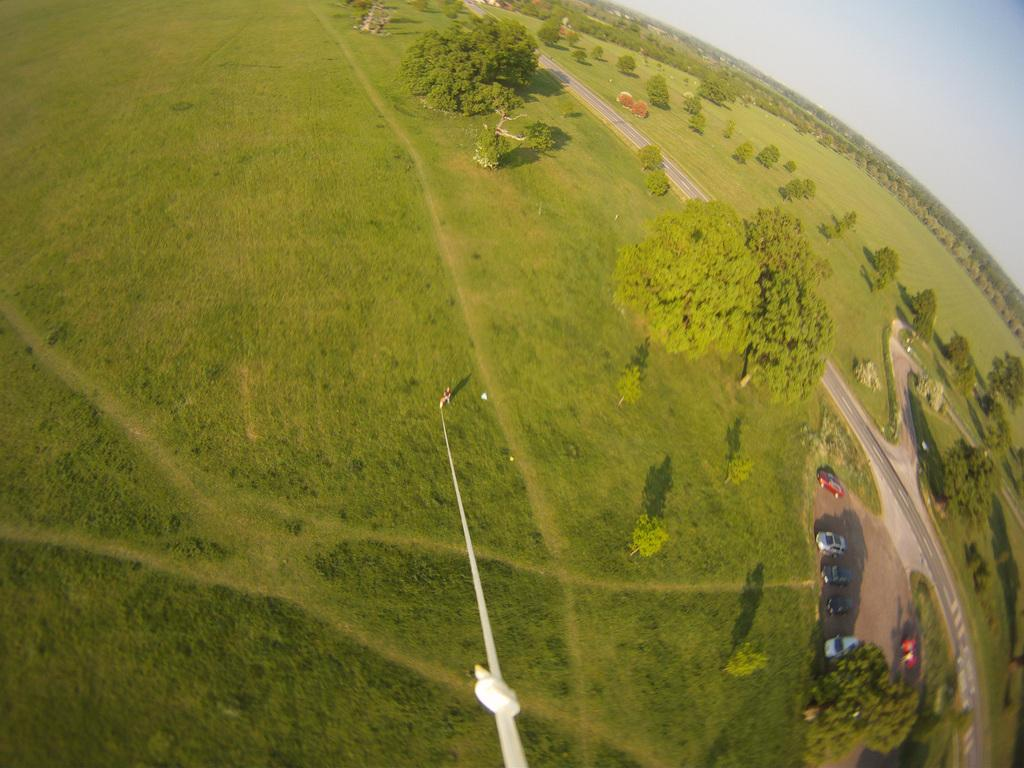What type of view is provided in the image? The image is a top view. What type of vegetation can be seen on the ground? There are trees and grass on the ground. What type of transportation is visible on the ground? There are vehicles on the ground. What type of pathway is visible in the image? There is a road visible in the image. What type of structure is present in the image? There is a pole in the image. Are there any people visible in the image? Yes, there is a person in the image. What part of the natural environment is visible in the image? The sky is visible in the image. What type of brush is being used by the person in the image? There is no brush visible in the image; the person is not holding or using any brush. 